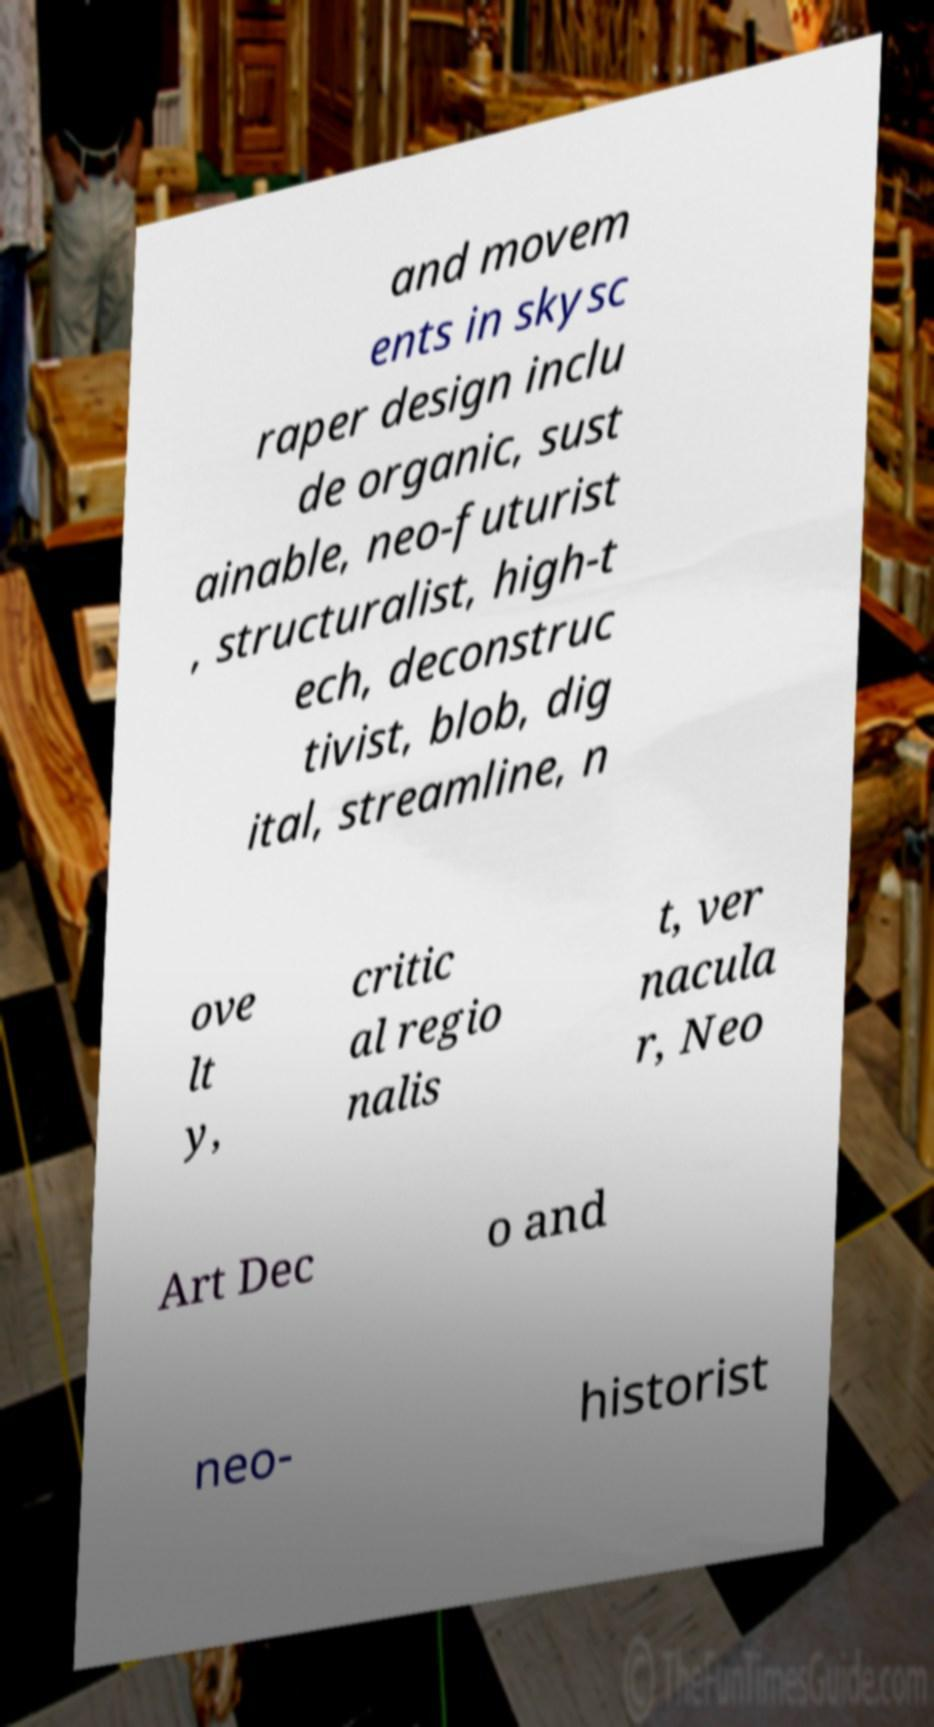Can you accurately transcribe the text from the provided image for me? and movem ents in skysc raper design inclu de organic, sust ainable, neo-futurist , structuralist, high-t ech, deconstruc tivist, blob, dig ital, streamline, n ove lt y, critic al regio nalis t, ver nacula r, Neo Art Dec o and neo- historist 